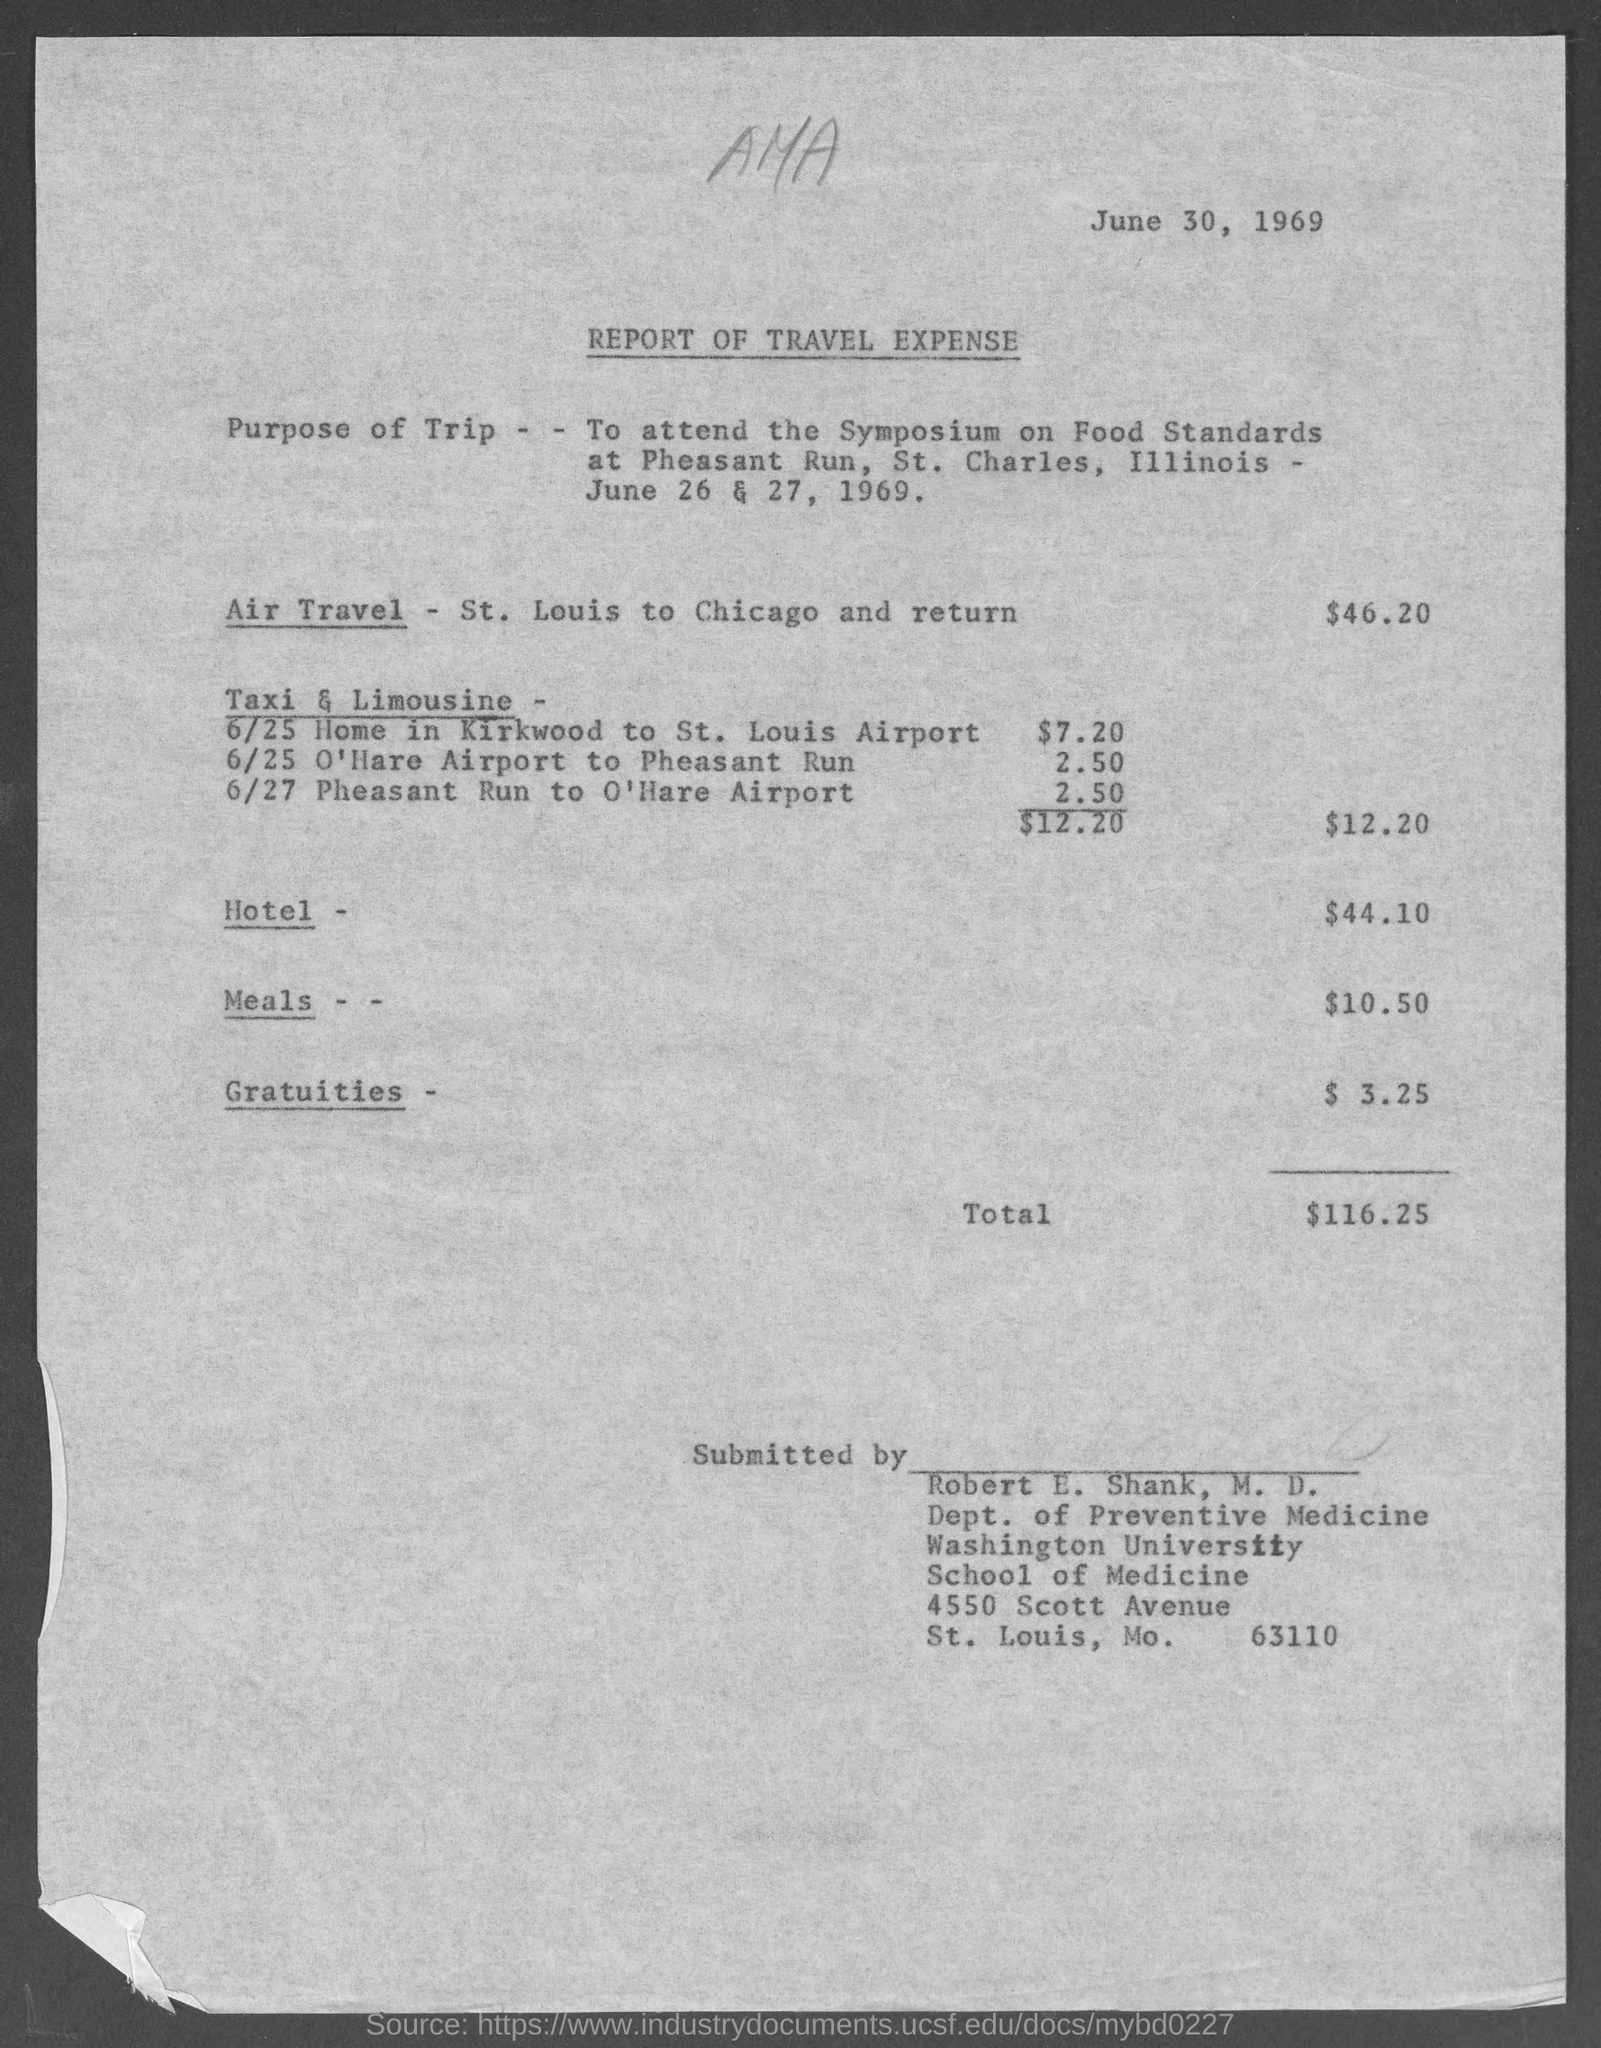What is the issued date of the travel expense report?
Give a very brief answer. June 30, 1969. When is the Symposium on Food Standards at Pheasant Run, St. Charles, illinois held?
Provide a succinct answer. June 26 & 27, 1969. What is the air travel expense as per the report?
Provide a short and direct response. $46.20. What is the hotel expense given in the report?
Ensure brevity in your answer.  44.10. What is the total travel expense given in the report?
Provide a succinct answer. $116.25. Who has submitted the travel expense report?
Make the answer very short. Robert E. Shank. In which department, Robert E. Shank,  M.D. works?
Provide a short and direct response. Dept. of Preventive Medicine. 